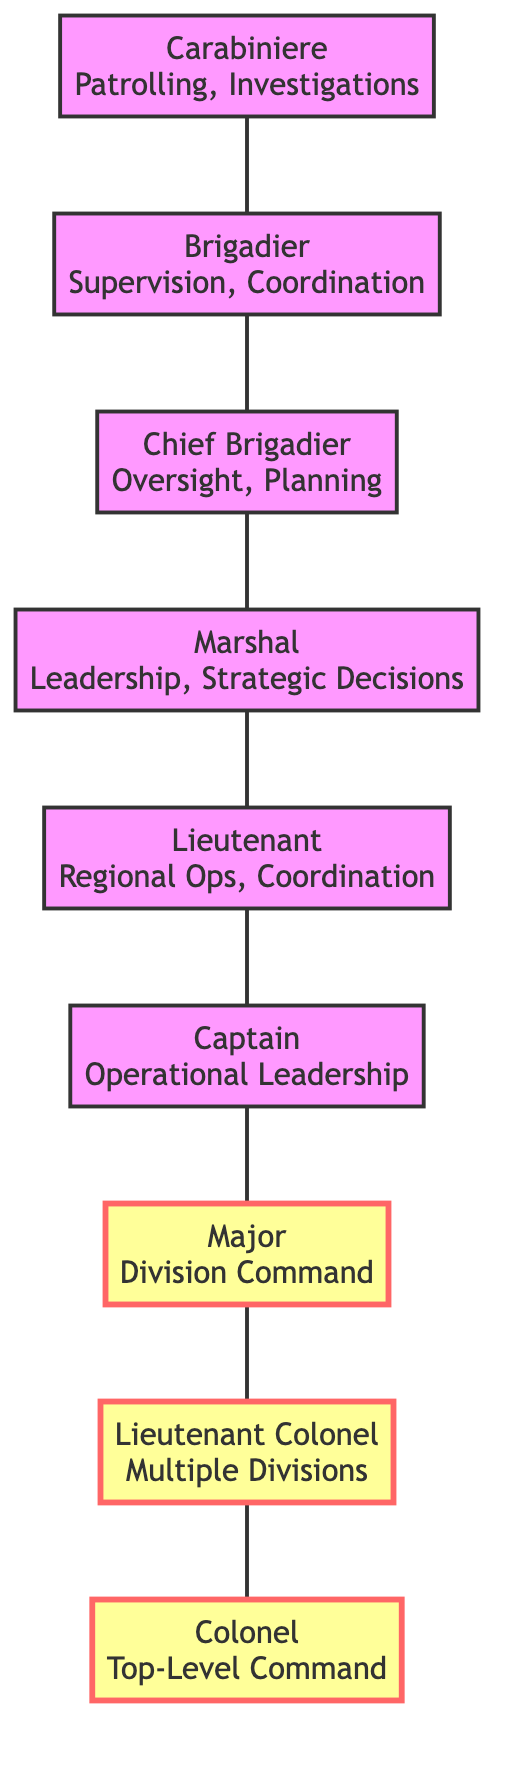What is the highest rank in the chain of command? The highest rank shown in the diagram is the Colonel, who is at the top of the hierarchy with no one above him.
Answer: Colonel How many roles or tasks does the Carabiniere have? The Carabiniere has two roles or tasks: Patrolling and Investigations, both of which are listed under their node.
Answer: 2 Who does the Lieutenant report to? According to the diagram, the Lieutenant reports to the Captain, which is indicated in their relationship in the graph.
Answer: Captain Which position supervises the Chief Brigadier? The Chief Brigadier is supervised by the Marshal, as depicted in the flow of supervision in the graph.
Answer: Marshal How many nodes are connected directly to the Colonel? The diagram shows that the Colonel supervises one node directly, which is the Lieutenant Colonel.
Answer: 1 What is the primary focus of the Major's roles or tasks? The Major's primary focus is on Division Command and Oversight of Key Operations, as listed in the Major's node information.
Answer: Division Command, Oversight of Key Operations Which position has oversight over Brigade Operations? The Chief Brigadier has oversight over Brigade Operations, as mentioned in the roles or tasks associated with their node.
Answer: Chief Brigadier What is the role of the Lieutenant Colonel? The Lieutenant Colonel's role includes Command of Multiple Divisions and Strategic Initiatives, as described in their respective node.
Answer: Command of Multiple Divisions, Strategic Initiatives How many levels of supervision are there between the Carabiniere and the Colonel? To reach from the Carabiniere to the Colonel, there are seven levels of supervision: Carabiniere → Brigadier → Chief Brigadier → Marshal → Lieutenant → Captain → Major → Lieutenant Colonel → Colonel.
Answer: 7 